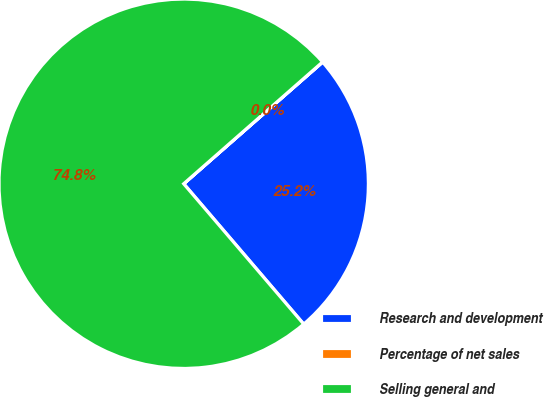Convert chart. <chart><loc_0><loc_0><loc_500><loc_500><pie_chart><fcel>Research and development<fcel>Percentage of net sales<fcel>Selling general and<nl><fcel>25.19%<fcel>0.01%<fcel>74.8%<nl></chart> 